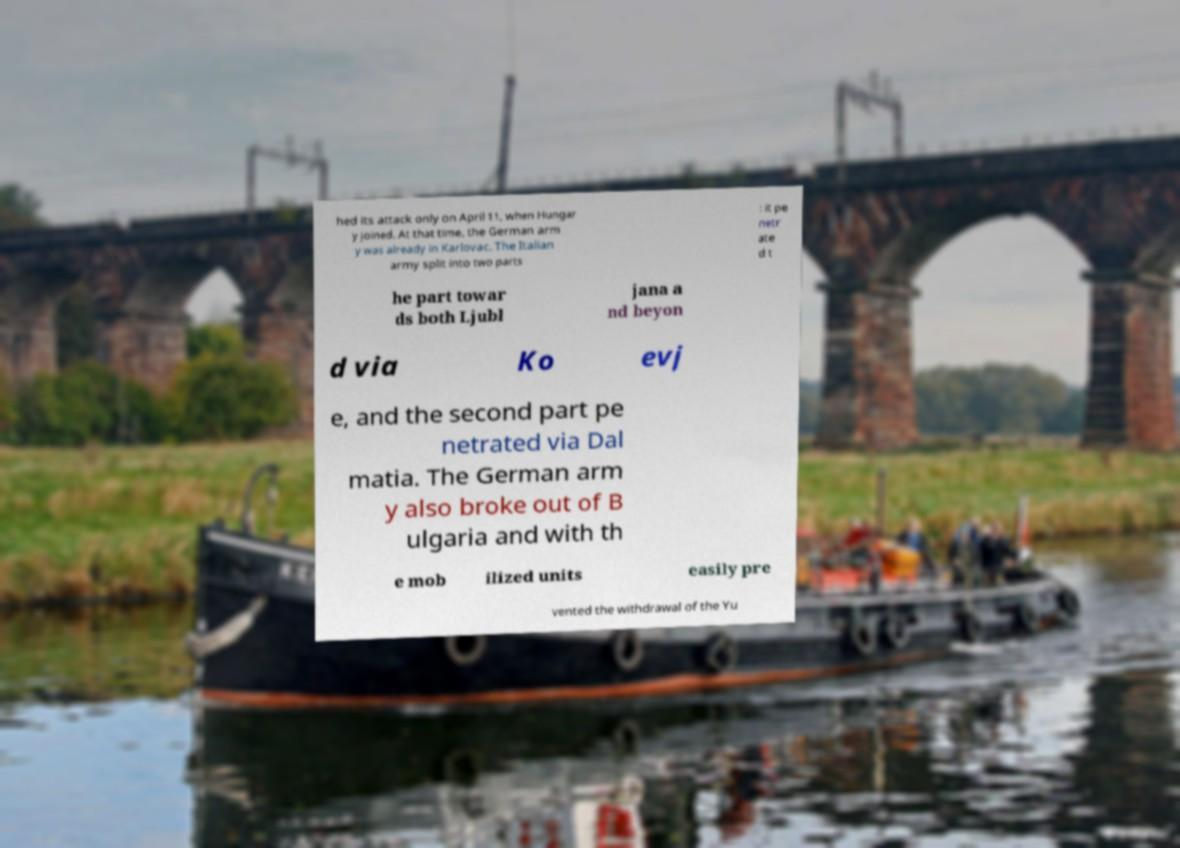Could you extract and type out the text from this image? hed its attack only on April 11, when Hungar y joined. At that time, the German arm y was already in Karlovac. The Italian army split into two parts : it pe netr ate d t he part towar ds both Ljubl jana a nd beyon d via Ko evj e, and the second part pe netrated via Dal matia. The German arm y also broke out of B ulgaria and with th e mob ilized units easily pre vented the withdrawal of the Yu 